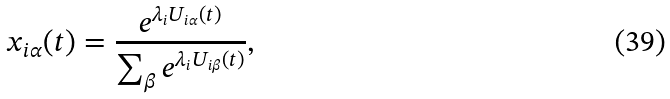Convert formula to latex. <formula><loc_0><loc_0><loc_500><loc_500>x _ { i \alpha } ( t ) = \frac { e ^ { \lambda _ { i } U _ { i \alpha } ( t ) } } { \sum _ { \beta } e ^ { \lambda _ { i } U _ { i \beta } ( t ) } } ,</formula> 